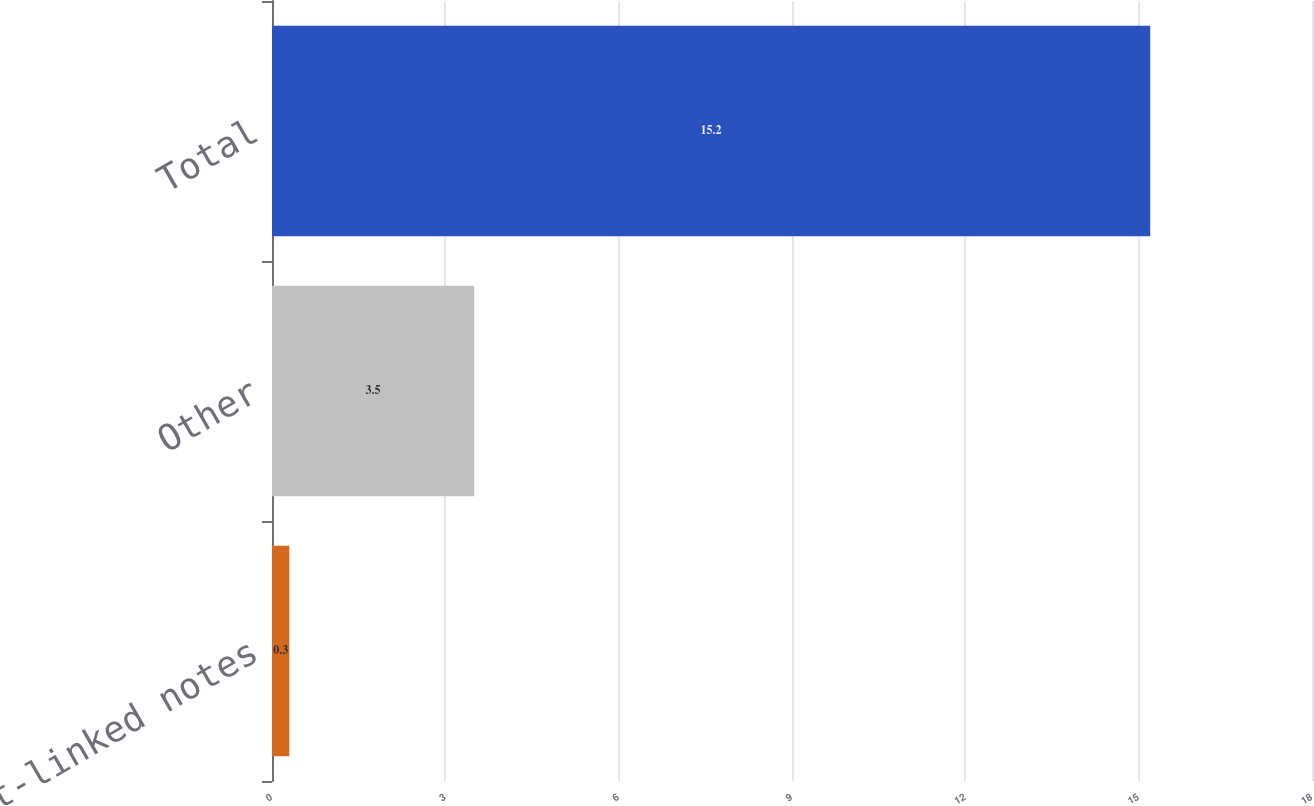<chart> <loc_0><loc_0><loc_500><loc_500><bar_chart><fcel>Credit-linked notes<fcel>Other<fcel>Total<nl><fcel>0.3<fcel>3.5<fcel>15.2<nl></chart> 